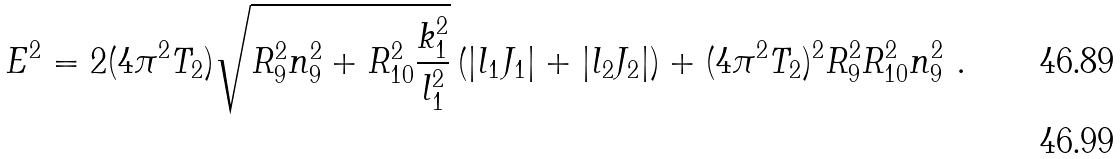<formula> <loc_0><loc_0><loc_500><loc_500>E ^ { 2 } & = 2 ( 4 \pi ^ { 2 } T _ { 2 } ) \sqrt { R _ { 9 } ^ { 2 } n _ { 9 } ^ { 2 } + R _ { 1 0 } ^ { 2 } \frac { k _ { 1 } ^ { 2 } } { l _ { 1 } ^ { 2 } } } \left ( | l _ { 1 } J _ { 1 } | + | l _ { 2 } J _ { 2 } | \right ) + ( 4 \pi ^ { 2 } T _ { 2 } ) ^ { 2 } R _ { 9 } ^ { 2 } R _ { 1 0 } ^ { 2 } n _ { 9 } ^ { 2 } \ . \\</formula> 